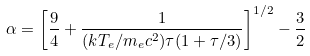<formula> <loc_0><loc_0><loc_500><loc_500>\alpha = \left [ \frac { 9 } { 4 } + \frac { 1 } { ( k T _ { e } / m _ { e } c ^ { 2 } ) \tau ( 1 + \tau / 3 ) } \right ] ^ { 1 / 2 } - \frac { 3 } { 2 }</formula> 